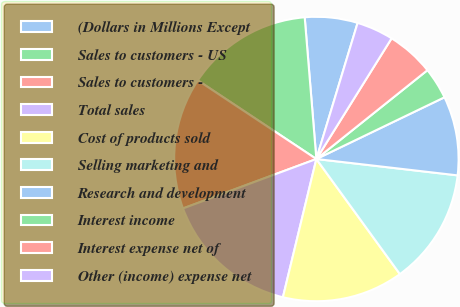Convert chart to OTSL. <chart><loc_0><loc_0><loc_500><loc_500><pie_chart><fcel>(Dollars in Millions Except<fcel>Sales to customers - US<fcel>Sales to customers -<fcel>Total sales<fcel>Cost of products sold<fcel>Selling marketing and<fcel>Research and development<fcel>Interest income<fcel>Interest expense net of<fcel>Other (income) expense net<nl><fcel>5.99%<fcel>14.37%<fcel>14.97%<fcel>15.57%<fcel>13.77%<fcel>13.17%<fcel>8.98%<fcel>3.59%<fcel>5.39%<fcel>4.19%<nl></chart> 